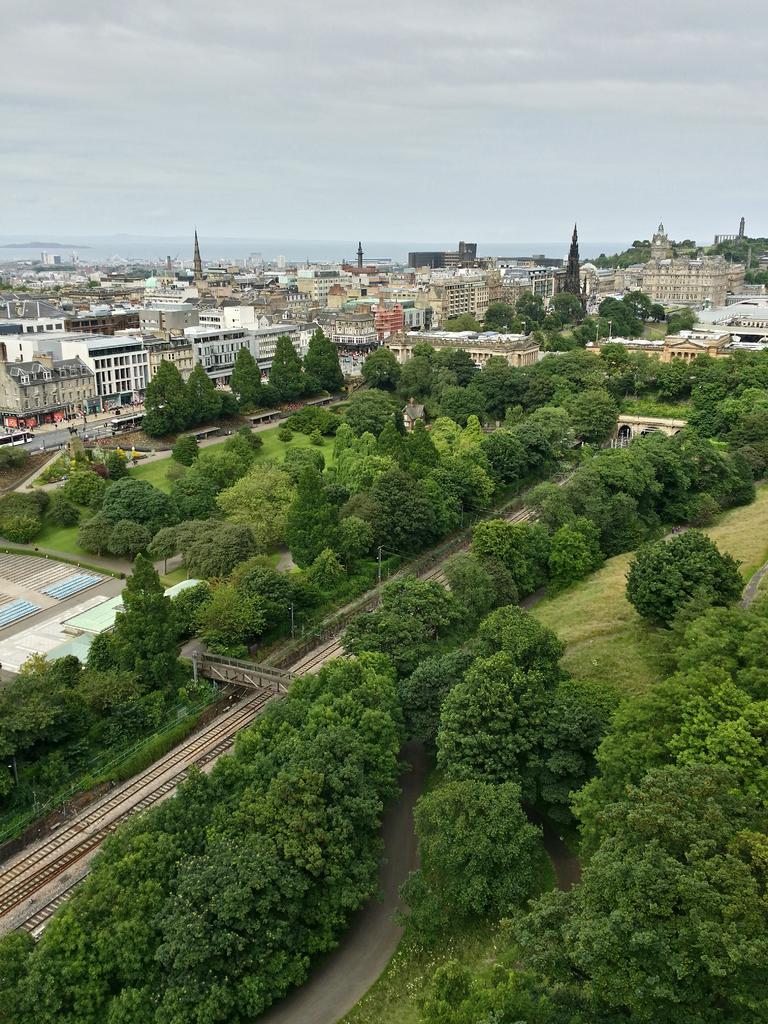In one or two sentences, can you explain what this image depicts? This picture is taken from outside of the city. In this image, we can see some trees, plants, buildings, houses, mountains. At the top, we can see a sky which is cloudy, at the bottom, we can see a bridge and a railway track. 